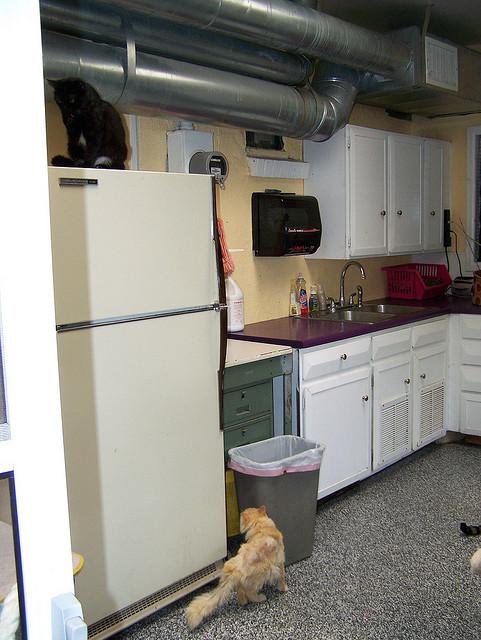Is the cat digging through the trash?
Keep it brief. No. How many cats do you see?
Be succinct. 2. What color is the trash can?
Write a very short answer. Gray. 